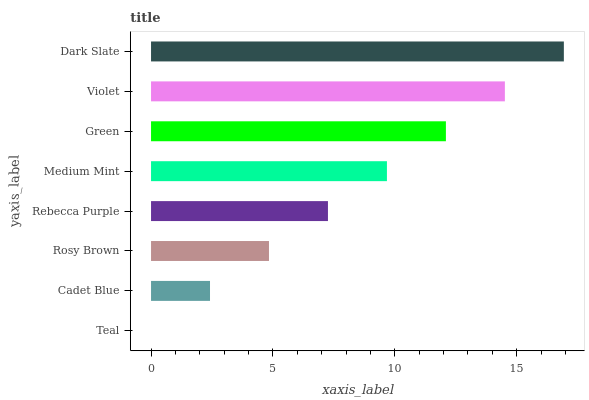Is Teal the minimum?
Answer yes or no. Yes. Is Dark Slate the maximum?
Answer yes or no. Yes. Is Cadet Blue the minimum?
Answer yes or no. No. Is Cadet Blue the maximum?
Answer yes or no. No. Is Cadet Blue greater than Teal?
Answer yes or no. Yes. Is Teal less than Cadet Blue?
Answer yes or no. Yes. Is Teal greater than Cadet Blue?
Answer yes or no. No. Is Cadet Blue less than Teal?
Answer yes or no. No. Is Medium Mint the high median?
Answer yes or no. Yes. Is Rebecca Purple the low median?
Answer yes or no. Yes. Is Rebecca Purple the high median?
Answer yes or no. No. Is Dark Slate the low median?
Answer yes or no. No. 